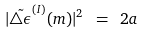<formula> <loc_0><loc_0><loc_500><loc_500>| \tilde { \triangle \epsilon } ^ { ( I ) } ( m ) | ^ { 2 } \ = \ 2 a \\</formula> 